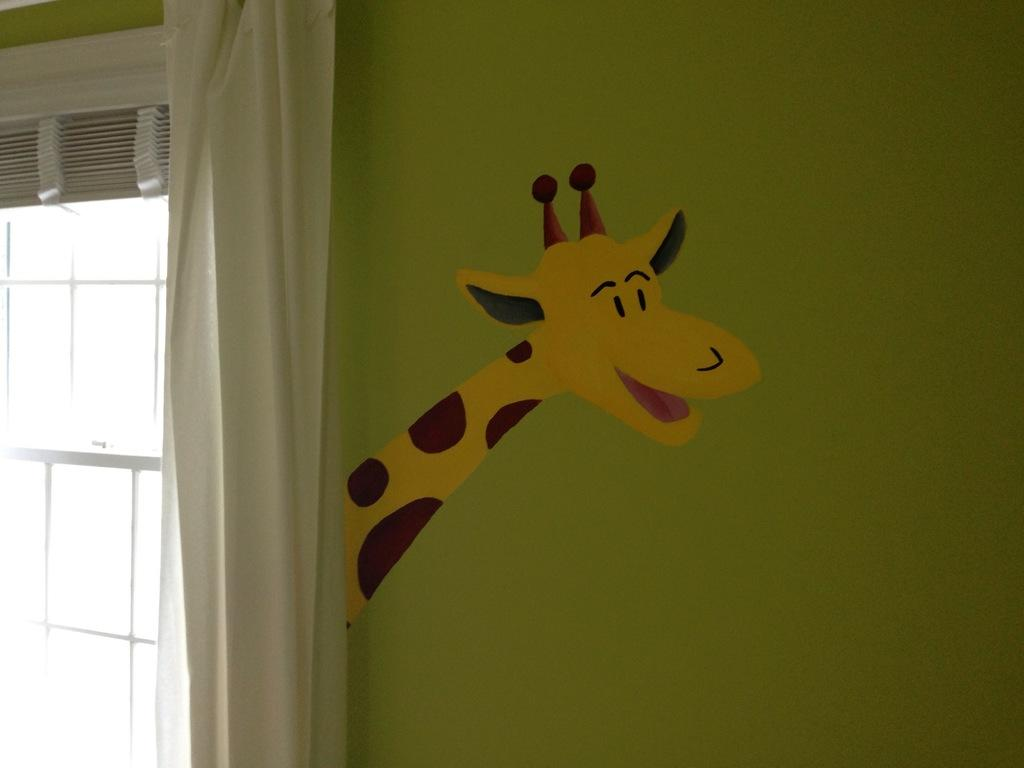What is painted in the image? There is a painted wall in the image. What can be seen on the wall? The provided facts do not mention any specific details about the wall's appearance. What architectural feature is present in the image? There is a window in the image. What is associated with the window? There is a curtain associated with the window. What is the acoustics of the room like in the image? The provided facts do not mention any details about the room acoustics or sound properties in the image. 